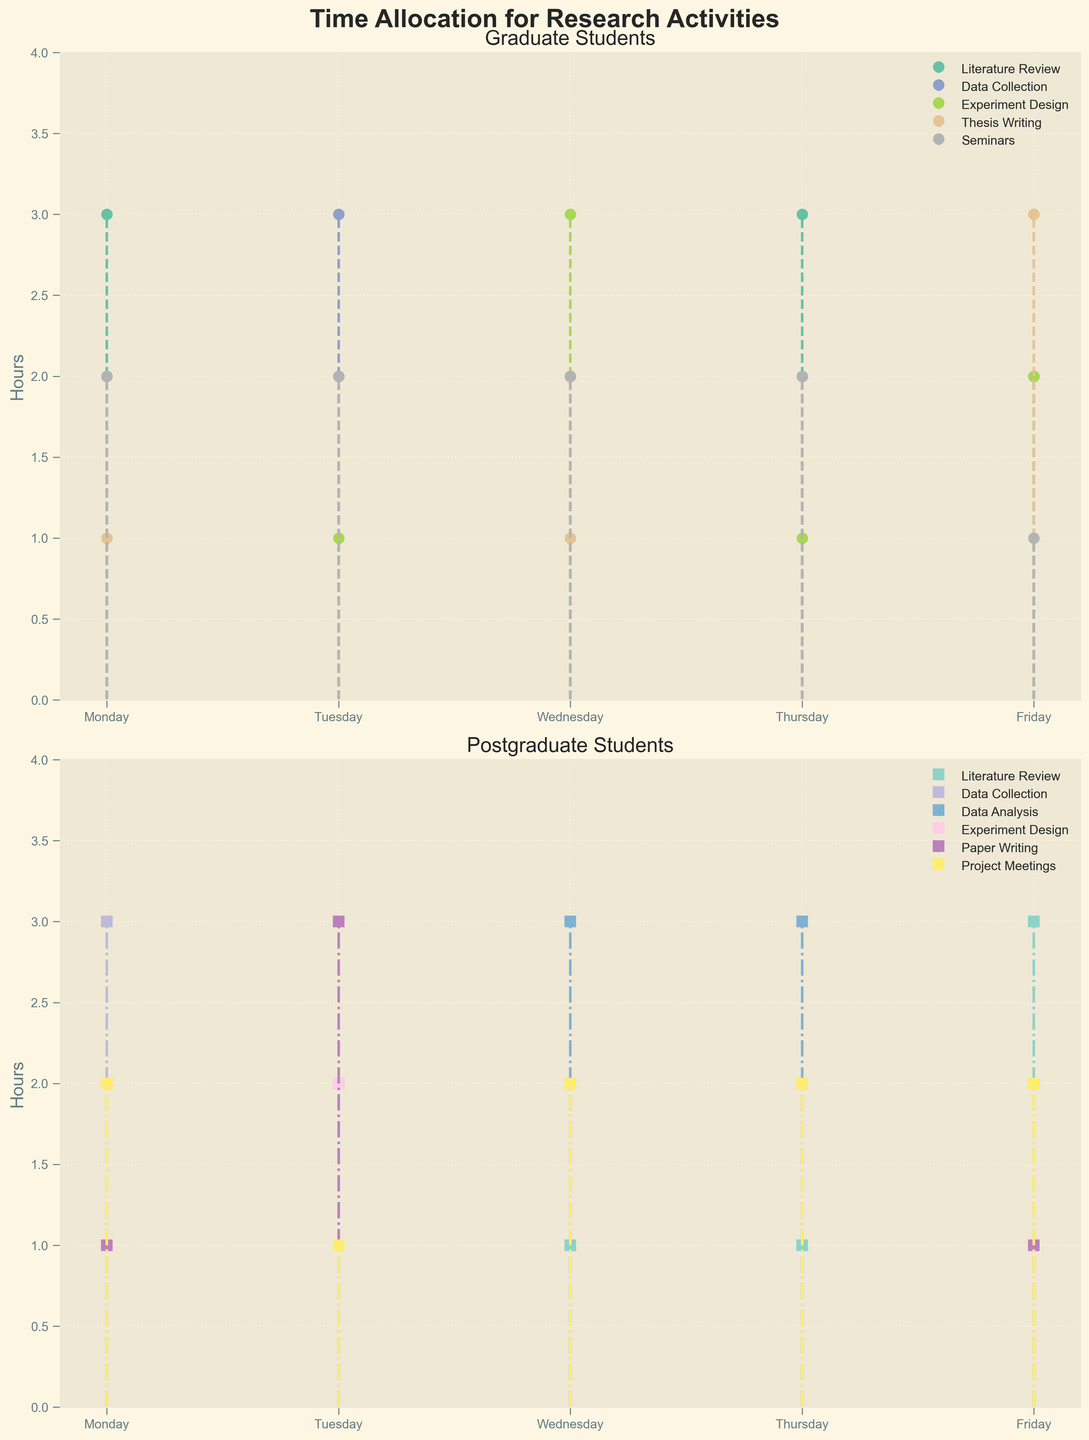What's the title of the upper subplot? The title of the upper subplot is displayed at the top of the first subplot. The titles typically provide a brief description of the data being presented. In this subplot, it shows "Graduate Students".
Answer: Graduate Students Which day do graduate students spend the most hours on Experiment Design? For graduate students, we need to look at the data points corresponding to Experiment Design in the first subplot. The color assigned to Experiment Design should be identified and cross-referenced across the days: Monday (2), Tuesday (1), Wednesday (3), Thursday (1), and Friday (2).
Answer: Wednesday How many hours do postgraduate students spend on Data Analysis on Wednesday? To find this, look at the second subplot where Data Analysis is visualized for postgraduates. Identify the color marking for Data Analysis and check the data point for Wednesday. The corresponding y-value will give the hours spent.
Answer: 3 On which day do postgraduate students spend the least total hours on their activities? For this, we need to sum the hours spent on all activities for each day and compare the totals. Postgraduate activities include Literature Review, Data Collection, Data Analysis, Experiment Design, Paper Writing, and Project Meetings. Evaluate each day’s total: Monday (10), Tuesday (10), Wednesday (10), Thursday (10), and Friday (10). Since all days have equal time allocation, there is no specific day with the least hours.
Answer: No specific day Which activity takes the most time for graduate students on Friday? Check the first subplot and find Friday’s data points for each activity based on color codes: Literature Review (2), Data Collection (2), Experiment Design (2), Thesis Writing (3), and Seminars (1). The activity corresponding to the highest value is Thesis Writing.
Answer: Thesis Writing Compare the total hours spent on Literature Review by both graduate and postgraduate students on Monday. Which group spends more time? For graduate students, the Literature Review on Monday is 3 hours. For postgraduates, it is 2 hours. By comparing these values, we see that graduate students spend more time on Literature Review on Monday.
Answer: Graduate students Which activity has more hours spent on average across the week by postgraduate students: Experiment Design or Paper Writing? Calculate the average hours for both activities by finding their total hours over the week and dividing by the number of days (5). Experiment Design: (2+2+2+2+2)/5 = 2; Paper Writing: (1+3+2+2+1)/5 = 1.8. Thus, Experiment Design has more average hours.
Answer: Experiment Design What is the difference in the number of hours spent on Paper Writing between Tuesday and Wednesday by postgraduate students? For Paper Writing on Tuesday, look at the value: 3 hours. On Wednesday, it is 2 hours. Subtracting these gives the difference: 3 - 2 = 1 hour.
Answer: 1 hour Which day has the most diverse activities for postgraduate students based on the different activities reported? To identify diversity, count the number of different activities for each day. Monday (5 different activities), Tuesday (5), Wednesday (5), Thursday (5), and Friday (5). Every day has 5 different activities listed, so all days are equally diverse.
Answer: All days are equally diverse 